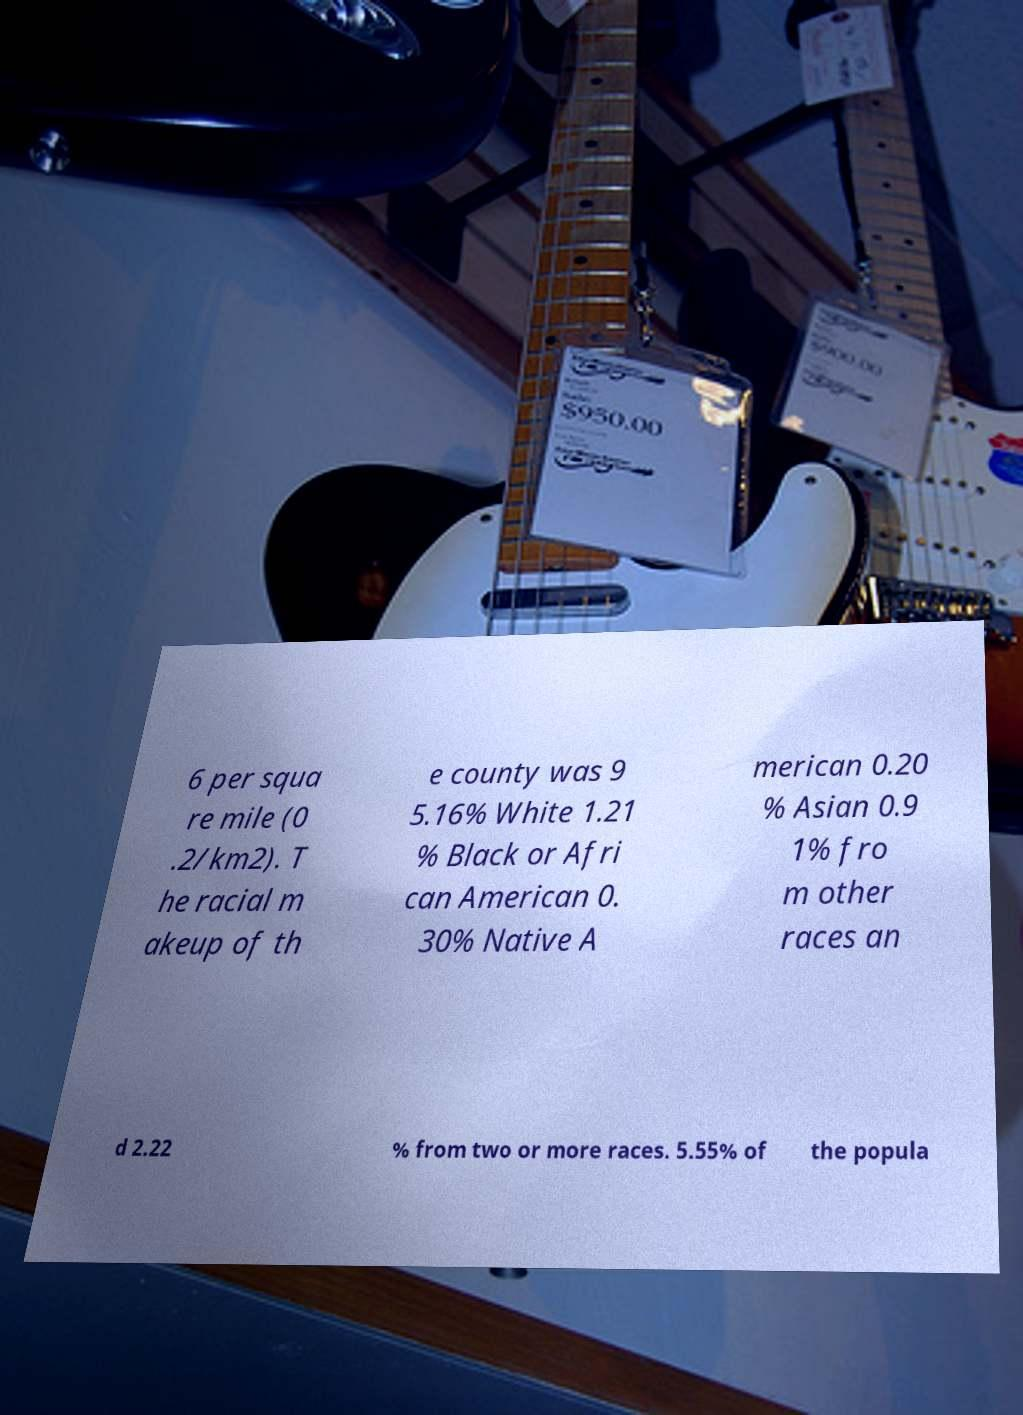Can you read and provide the text displayed in the image?This photo seems to have some interesting text. Can you extract and type it out for me? 6 per squa re mile (0 .2/km2). T he racial m akeup of th e county was 9 5.16% White 1.21 % Black or Afri can American 0. 30% Native A merican 0.20 % Asian 0.9 1% fro m other races an d 2.22 % from two or more races. 5.55% of the popula 